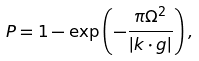<formula> <loc_0><loc_0><loc_500><loc_500>P = 1 - \exp \left ( - \frac { \pi \Omega ^ { 2 } } { \left | k \cdot g \right | } \right ) ,</formula> 